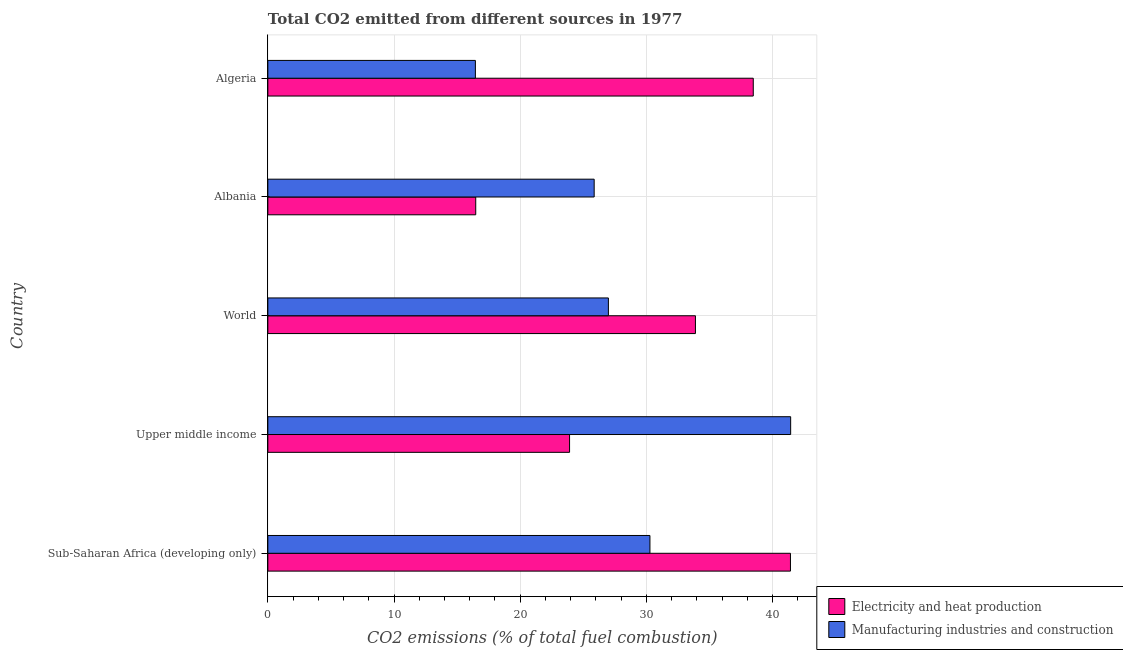Are the number of bars per tick equal to the number of legend labels?
Make the answer very short. Yes. Are the number of bars on each tick of the Y-axis equal?
Provide a succinct answer. Yes. How many bars are there on the 3rd tick from the top?
Your answer should be compact. 2. What is the label of the 1st group of bars from the top?
Provide a succinct answer. Algeria. What is the co2 emissions due to manufacturing industries in Algeria?
Provide a succinct answer. 16.45. Across all countries, what is the maximum co2 emissions due to electricity and heat production?
Make the answer very short. 41.42. Across all countries, what is the minimum co2 emissions due to electricity and heat production?
Offer a very short reply. 16.48. In which country was the co2 emissions due to manufacturing industries maximum?
Your response must be concise. Upper middle income. In which country was the co2 emissions due to electricity and heat production minimum?
Make the answer very short. Albania. What is the total co2 emissions due to manufacturing industries in the graph?
Keep it short and to the point. 141.01. What is the difference between the co2 emissions due to manufacturing industries in Albania and that in World?
Provide a succinct answer. -1.13. What is the difference between the co2 emissions due to electricity and heat production in World and the co2 emissions due to manufacturing industries in Algeria?
Keep it short and to the point. 17.44. What is the average co2 emissions due to electricity and heat production per country?
Your answer should be very brief. 30.83. What is the difference between the co2 emissions due to electricity and heat production and co2 emissions due to manufacturing industries in Sub-Saharan Africa (developing only)?
Keep it short and to the point. 11.14. In how many countries, is the co2 emissions due to electricity and heat production greater than 22 %?
Your answer should be very brief. 4. What is the ratio of the co2 emissions due to electricity and heat production in Upper middle income to that in World?
Provide a short and direct response. 0.71. Is the co2 emissions due to electricity and heat production in Algeria less than that in World?
Offer a very short reply. No. What is the difference between the highest and the second highest co2 emissions due to manufacturing industries?
Provide a succinct answer. 11.15. What is the difference between the highest and the lowest co2 emissions due to electricity and heat production?
Ensure brevity in your answer.  24.94. In how many countries, is the co2 emissions due to manufacturing industries greater than the average co2 emissions due to manufacturing industries taken over all countries?
Your response must be concise. 2. Is the sum of the co2 emissions due to manufacturing industries in Albania and Sub-Saharan Africa (developing only) greater than the maximum co2 emissions due to electricity and heat production across all countries?
Your answer should be very brief. Yes. What does the 2nd bar from the top in Albania represents?
Provide a short and direct response. Electricity and heat production. What does the 2nd bar from the bottom in Upper middle income represents?
Offer a very short reply. Manufacturing industries and construction. How many bars are there?
Your answer should be compact. 10. Are all the bars in the graph horizontal?
Your response must be concise. Yes. How many countries are there in the graph?
Give a very brief answer. 5. Does the graph contain grids?
Give a very brief answer. Yes. Where does the legend appear in the graph?
Ensure brevity in your answer.  Bottom right. How many legend labels are there?
Offer a very short reply. 2. How are the legend labels stacked?
Your answer should be compact. Vertical. What is the title of the graph?
Keep it short and to the point. Total CO2 emitted from different sources in 1977. Does "Revenue" appear as one of the legend labels in the graph?
Ensure brevity in your answer.  No. What is the label or title of the X-axis?
Provide a short and direct response. CO2 emissions (% of total fuel combustion). What is the CO2 emissions (% of total fuel combustion) in Electricity and heat production in Sub-Saharan Africa (developing only)?
Offer a terse response. 41.42. What is the CO2 emissions (% of total fuel combustion) in Manufacturing industries and construction in Sub-Saharan Africa (developing only)?
Your answer should be very brief. 30.28. What is the CO2 emissions (% of total fuel combustion) in Electricity and heat production in Upper middle income?
Provide a short and direct response. 23.91. What is the CO2 emissions (% of total fuel combustion) of Manufacturing industries and construction in Upper middle income?
Ensure brevity in your answer.  41.43. What is the CO2 emissions (% of total fuel combustion) in Electricity and heat production in World?
Your answer should be compact. 33.89. What is the CO2 emissions (% of total fuel combustion) of Manufacturing industries and construction in World?
Make the answer very short. 26.99. What is the CO2 emissions (% of total fuel combustion) of Electricity and heat production in Albania?
Your answer should be compact. 16.48. What is the CO2 emissions (% of total fuel combustion) of Manufacturing industries and construction in Albania?
Give a very brief answer. 25.86. What is the CO2 emissions (% of total fuel combustion) of Electricity and heat production in Algeria?
Your answer should be very brief. 38.47. What is the CO2 emissions (% of total fuel combustion) of Manufacturing industries and construction in Algeria?
Make the answer very short. 16.45. Across all countries, what is the maximum CO2 emissions (% of total fuel combustion) of Electricity and heat production?
Ensure brevity in your answer.  41.42. Across all countries, what is the maximum CO2 emissions (% of total fuel combustion) of Manufacturing industries and construction?
Give a very brief answer. 41.43. Across all countries, what is the minimum CO2 emissions (% of total fuel combustion) in Electricity and heat production?
Your response must be concise. 16.48. Across all countries, what is the minimum CO2 emissions (% of total fuel combustion) in Manufacturing industries and construction?
Provide a short and direct response. 16.45. What is the total CO2 emissions (% of total fuel combustion) of Electricity and heat production in the graph?
Make the answer very short. 154.16. What is the total CO2 emissions (% of total fuel combustion) in Manufacturing industries and construction in the graph?
Your response must be concise. 141.01. What is the difference between the CO2 emissions (% of total fuel combustion) of Electricity and heat production in Sub-Saharan Africa (developing only) and that in Upper middle income?
Keep it short and to the point. 17.51. What is the difference between the CO2 emissions (% of total fuel combustion) in Manufacturing industries and construction in Sub-Saharan Africa (developing only) and that in Upper middle income?
Your answer should be very brief. -11.15. What is the difference between the CO2 emissions (% of total fuel combustion) of Electricity and heat production in Sub-Saharan Africa (developing only) and that in World?
Provide a succinct answer. 7.53. What is the difference between the CO2 emissions (% of total fuel combustion) in Manufacturing industries and construction in Sub-Saharan Africa (developing only) and that in World?
Give a very brief answer. 3.29. What is the difference between the CO2 emissions (% of total fuel combustion) in Electricity and heat production in Sub-Saharan Africa (developing only) and that in Albania?
Offer a terse response. 24.94. What is the difference between the CO2 emissions (% of total fuel combustion) of Manufacturing industries and construction in Sub-Saharan Africa (developing only) and that in Albania?
Provide a succinct answer. 4.42. What is the difference between the CO2 emissions (% of total fuel combustion) in Electricity and heat production in Sub-Saharan Africa (developing only) and that in Algeria?
Give a very brief answer. 2.95. What is the difference between the CO2 emissions (% of total fuel combustion) in Manufacturing industries and construction in Sub-Saharan Africa (developing only) and that in Algeria?
Offer a terse response. 13.83. What is the difference between the CO2 emissions (% of total fuel combustion) in Electricity and heat production in Upper middle income and that in World?
Offer a terse response. -9.97. What is the difference between the CO2 emissions (% of total fuel combustion) of Manufacturing industries and construction in Upper middle income and that in World?
Keep it short and to the point. 14.44. What is the difference between the CO2 emissions (% of total fuel combustion) in Electricity and heat production in Upper middle income and that in Albania?
Your answer should be very brief. 7.44. What is the difference between the CO2 emissions (% of total fuel combustion) in Manufacturing industries and construction in Upper middle income and that in Albania?
Offer a very short reply. 15.57. What is the difference between the CO2 emissions (% of total fuel combustion) in Electricity and heat production in Upper middle income and that in Algeria?
Provide a short and direct response. -14.56. What is the difference between the CO2 emissions (% of total fuel combustion) of Manufacturing industries and construction in Upper middle income and that in Algeria?
Provide a succinct answer. 24.98. What is the difference between the CO2 emissions (% of total fuel combustion) in Electricity and heat production in World and that in Albania?
Make the answer very short. 17.41. What is the difference between the CO2 emissions (% of total fuel combustion) of Manufacturing industries and construction in World and that in Albania?
Your answer should be very brief. 1.13. What is the difference between the CO2 emissions (% of total fuel combustion) of Electricity and heat production in World and that in Algeria?
Your answer should be very brief. -4.58. What is the difference between the CO2 emissions (% of total fuel combustion) in Manufacturing industries and construction in World and that in Algeria?
Your answer should be compact. 10.54. What is the difference between the CO2 emissions (% of total fuel combustion) in Electricity and heat production in Albania and that in Algeria?
Keep it short and to the point. -21.99. What is the difference between the CO2 emissions (% of total fuel combustion) of Manufacturing industries and construction in Albania and that in Algeria?
Your answer should be very brief. 9.41. What is the difference between the CO2 emissions (% of total fuel combustion) of Electricity and heat production in Sub-Saharan Africa (developing only) and the CO2 emissions (% of total fuel combustion) of Manufacturing industries and construction in Upper middle income?
Provide a succinct answer. -0.02. What is the difference between the CO2 emissions (% of total fuel combustion) of Electricity and heat production in Sub-Saharan Africa (developing only) and the CO2 emissions (% of total fuel combustion) of Manufacturing industries and construction in World?
Your answer should be very brief. 14.43. What is the difference between the CO2 emissions (% of total fuel combustion) of Electricity and heat production in Sub-Saharan Africa (developing only) and the CO2 emissions (% of total fuel combustion) of Manufacturing industries and construction in Albania?
Offer a terse response. 15.56. What is the difference between the CO2 emissions (% of total fuel combustion) in Electricity and heat production in Sub-Saharan Africa (developing only) and the CO2 emissions (% of total fuel combustion) in Manufacturing industries and construction in Algeria?
Give a very brief answer. 24.97. What is the difference between the CO2 emissions (% of total fuel combustion) of Electricity and heat production in Upper middle income and the CO2 emissions (% of total fuel combustion) of Manufacturing industries and construction in World?
Keep it short and to the point. -3.08. What is the difference between the CO2 emissions (% of total fuel combustion) of Electricity and heat production in Upper middle income and the CO2 emissions (% of total fuel combustion) of Manufacturing industries and construction in Albania?
Your answer should be compact. -1.95. What is the difference between the CO2 emissions (% of total fuel combustion) of Electricity and heat production in Upper middle income and the CO2 emissions (% of total fuel combustion) of Manufacturing industries and construction in Algeria?
Provide a short and direct response. 7.46. What is the difference between the CO2 emissions (% of total fuel combustion) in Electricity and heat production in World and the CO2 emissions (% of total fuel combustion) in Manufacturing industries and construction in Albania?
Provide a succinct answer. 8.02. What is the difference between the CO2 emissions (% of total fuel combustion) in Electricity and heat production in World and the CO2 emissions (% of total fuel combustion) in Manufacturing industries and construction in Algeria?
Your answer should be very brief. 17.44. What is the difference between the CO2 emissions (% of total fuel combustion) in Electricity and heat production in Albania and the CO2 emissions (% of total fuel combustion) in Manufacturing industries and construction in Algeria?
Offer a terse response. 0.03. What is the average CO2 emissions (% of total fuel combustion) in Electricity and heat production per country?
Your answer should be compact. 30.83. What is the average CO2 emissions (% of total fuel combustion) of Manufacturing industries and construction per country?
Keep it short and to the point. 28.2. What is the difference between the CO2 emissions (% of total fuel combustion) of Electricity and heat production and CO2 emissions (% of total fuel combustion) of Manufacturing industries and construction in Sub-Saharan Africa (developing only)?
Provide a short and direct response. 11.14. What is the difference between the CO2 emissions (% of total fuel combustion) in Electricity and heat production and CO2 emissions (% of total fuel combustion) in Manufacturing industries and construction in Upper middle income?
Provide a short and direct response. -17.52. What is the difference between the CO2 emissions (% of total fuel combustion) of Electricity and heat production and CO2 emissions (% of total fuel combustion) of Manufacturing industries and construction in World?
Give a very brief answer. 6.9. What is the difference between the CO2 emissions (% of total fuel combustion) in Electricity and heat production and CO2 emissions (% of total fuel combustion) in Manufacturing industries and construction in Albania?
Your answer should be very brief. -9.39. What is the difference between the CO2 emissions (% of total fuel combustion) in Electricity and heat production and CO2 emissions (% of total fuel combustion) in Manufacturing industries and construction in Algeria?
Your response must be concise. 22.02. What is the ratio of the CO2 emissions (% of total fuel combustion) of Electricity and heat production in Sub-Saharan Africa (developing only) to that in Upper middle income?
Provide a succinct answer. 1.73. What is the ratio of the CO2 emissions (% of total fuel combustion) in Manufacturing industries and construction in Sub-Saharan Africa (developing only) to that in Upper middle income?
Give a very brief answer. 0.73. What is the ratio of the CO2 emissions (% of total fuel combustion) of Electricity and heat production in Sub-Saharan Africa (developing only) to that in World?
Provide a short and direct response. 1.22. What is the ratio of the CO2 emissions (% of total fuel combustion) of Manufacturing industries and construction in Sub-Saharan Africa (developing only) to that in World?
Offer a terse response. 1.12. What is the ratio of the CO2 emissions (% of total fuel combustion) in Electricity and heat production in Sub-Saharan Africa (developing only) to that in Albania?
Ensure brevity in your answer.  2.51. What is the ratio of the CO2 emissions (% of total fuel combustion) in Manufacturing industries and construction in Sub-Saharan Africa (developing only) to that in Albania?
Your response must be concise. 1.17. What is the ratio of the CO2 emissions (% of total fuel combustion) in Electricity and heat production in Sub-Saharan Africa (developing only) to that in Algeria?
Provide a succinct answer. 1.08. What is the ratio of the CO2 emissions (% of total fuel combustion) in Manufacturing industries and construction in Sub-Saharan Africa (developing only) to that in Algeria?
Make the answer very short. 1.84. What is the ratio of the CO2 emissions (% of total fuel combustion) of Electricity and heat production in Upper middle income to that in World?
Offer a terse response. 0.71. What is the ratio of the CO2 emissions (% of total fuel combustion) in Manufacturing industries and construction in Upper middle income to that in World?
Give a very brief answer. 1.54. What is the ratio of the CO2 emissions (% of total fuel combustion) in Electricity and heat production in Upper middle income to that in Albania?
Provide a succinct answer. 1.45. What is the ratio of the CO2 emissions (% of total fuel combustion) in Manufacturing industries and construction in Upper middle income to that in Albania?
Provide a short and direct response. 1.6. What is the ratio of the CO2 emissions (% of total fuel combustion) in Electricity and heat production in Upper middle income to that in Algeria?
Make the answer very short. 0.62. What is the ratio of the CO2 emissions (% of total fuel combustion) in Manufacturing industries and construction in Upper middle income to that in Algeria?
Provide a succinct answer. 2.52. What is the ratio of the CO2 emissions (% of total fuel combustion) in Electricity and heat production in World to that in Albania?
Make the answer very short. 2.06. What is the ratio of the CO2 emissions (% of total fuel combustion) in Manufacturing industries and construction in World to that in Albania?
Give a very brief answer. 1.04. What is the ratio of the CO2 emissions (% of total fuel combustion) of Electricity and heat production in World to that in Algeria?
Your answer should be very brief. 0.88. What is the ratio of the CO2 emissions (% of total fuel combustion) in Manufacturing industries and construction in World to that in Algeria?
Provide a succinct answer. 1.64. What is the ratio of the CO2 emissions (% of total fuel combustion) in Electricity and heat production in Albania to that in Algeria?
Your answer should be very brief. 0.43. What is the ratio of the CO2 emissions (% of total fuel combustion) in Manufacturing industries and construction in Albania to that in Algeria?
Your answer should be very brief. 1.57. What is the difference between the highest and the second highest CO2 emissions (% of total fuel combustion) of Electricity and heat production?
Provide a short and direct response. 2.95. What is the difference between the highest and the second highest CO2 emissions (% of total fuel combustion) of Manufacturing industries and construction?
Provide a succinct answer. 11.15. What is the difference between the highest and the lowest CO2 emissions (% of total fuel combustion) of Electricity and heat production?
Offer a terse response. 24.94. What is the difference between the highest and the lowest CO2 emissions (% of total fuel combustion) of Manufacturing industries and construction?
Make the answer very short. 24.98. 